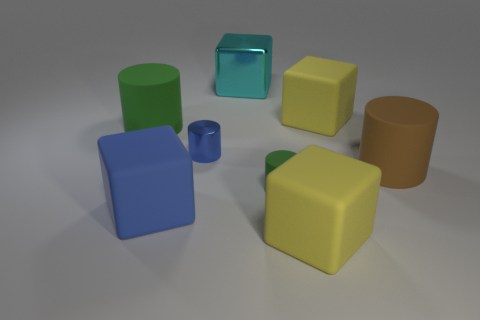What number of objects are either yellow matte cubes in front of the brown object or big matte objects that are to the right of the small blue shiny thing?
Make the answer very short. 3. There is a thing that is both behind the large blue matte block and to the left of the blue metal thing; what color is it?
Your response must be concise. Green. Is the number of big brown rubber cylinders greater than the number of yellow spheres?
Offer a terse response. Yes. Do the metallic thing in front of the big cyan thing and the brown object have the same shape?
Provide a short and direct response. Yes. How many metal things are small cyan balls or large green cylinders?
Offer a terse response. 0. Is there a big block that has the same material as the large brown object?
Provide a short and direct response. Yes. What is the material of the brown thing?
Keep it short and to the point. Rubber. There is a yellow object behind the large yellow cube in front of the big yellow cube that is behind the brown rubber thing; what is its shape?
Provide a succinct answer. Cube. Is the number of large blue objects that are in front of the tiny rubber cylinder greater than the number of large yellow metal spheres?
Keep it short and to the point. Yes. Is the shape of the large blue rubber object the same as the shiny thing behind the large green matte cylinder?
Provide a short and direct response. Yes. 